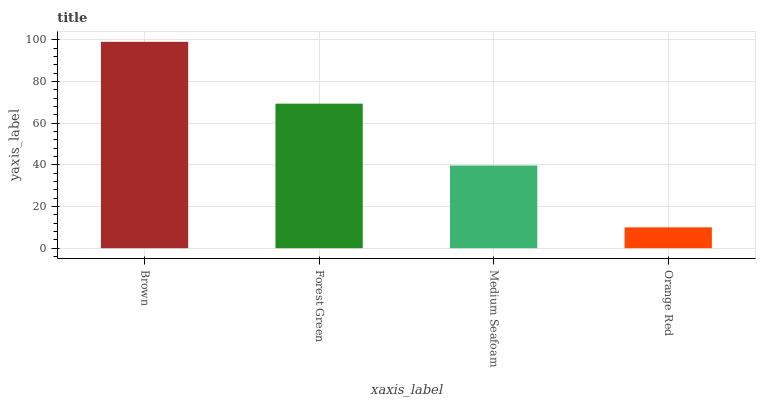Is Orange Red the minimum?
Answer yes or no. Yes. Is Brown the maximum?
Answer yes or no. Yes. Is Forest Green the minimum?
Answer yes or no. No. Is Forest Green the maximum?
Answer yes or no. No. Is Brown greater than Forest Green?
Answer yes or no. Yes. Is Forest Green less than Brown?
Answer yes or no. Yes. Is Forest Green greater than Brown?
Answer yes or no. No. Is Brown less than Forest Green?
Answer yes or no. No. Is Forest Green the high median?
Answer yes or no. Yes. Is Medium Seafoam the low median?
Answer yes or no. Yes. Is Orange Red the high median?
Answer yes or no. No. Is Orange Red the low median?
Answer yes or no. No. 